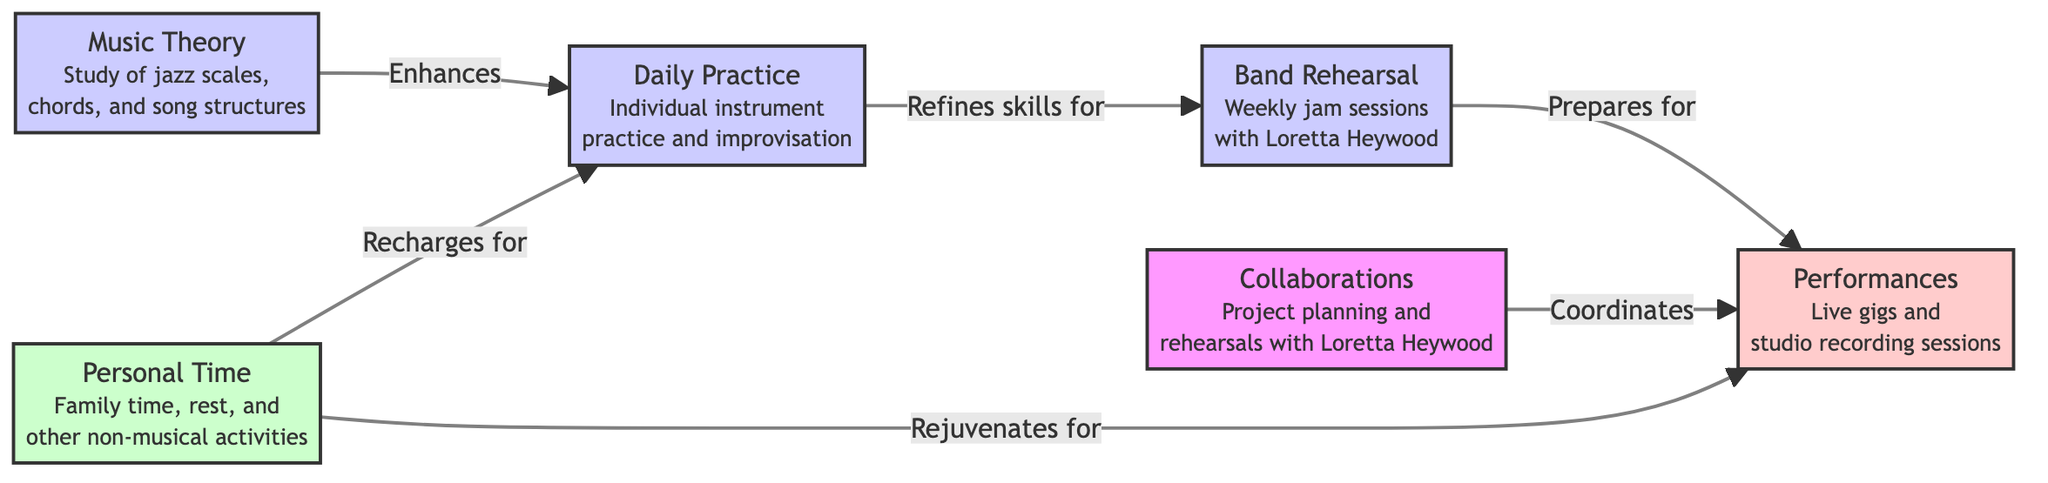What are the three main components of a jazz musician's weekly schedule? The diagram presents three main components: daily practice, performances, and personal time. These components are clearly labeled in distinct categories.
Answer: daily practice, performances, personal time How does daily practice relate to band rehearsal? The diagram shows an arrow from daily practice to band rehearsal with the label "Refines skills for." This indicates that the skills developed during daily practice are essential for successful band rehearsals.
Answer: Refines skills for What is the role of music theory in the daily practice? According to the diagram, there is a connection from music theory to daily practice labeled "Enhances.” This suggests that studying music theory improves the effectiveness of daily practice.
Answer: Enhances Which activity prepares a musician for performances? The diagram illustrates that band rehearsal connects to performances, labeled "Prepares for." This means that the preparation done during band rehearsals is geared towards upcoming performances.
Answer: Prepares for How many edges connect the nodes in the diagram? The diagram features six arrows connecting the nodes, representing various relationships between components of the jazz musician's practice schedule. By counting these arrows, we find a total of six edges.
Answer: 6 What is provided by personal time in the context of daily practice? The diagram represents personal time connecting to daily practice with the label "Recharges for." This relationship indicates that personal time is crucial for rest and rejuvenation to support effective daily practice.
Answer: Recharges for What relationship exists between collaborations and performances? The diagram shows arrows connecting collaborations to performances with the label "Coordinates." This signifies that collaborations help to plan and organize performances effectively.
Answer: Coordinates What does the 'Band Rehearsal' node specifically refer to? The 'Band Rehearsal' node includes a description specifying it is for "Weekly jam sessions with Loretta Heywood," indicating that collaboration with Loretta is a key aspect of this activity.
Answer: Weekly jam sessions with Loretta Heywood 